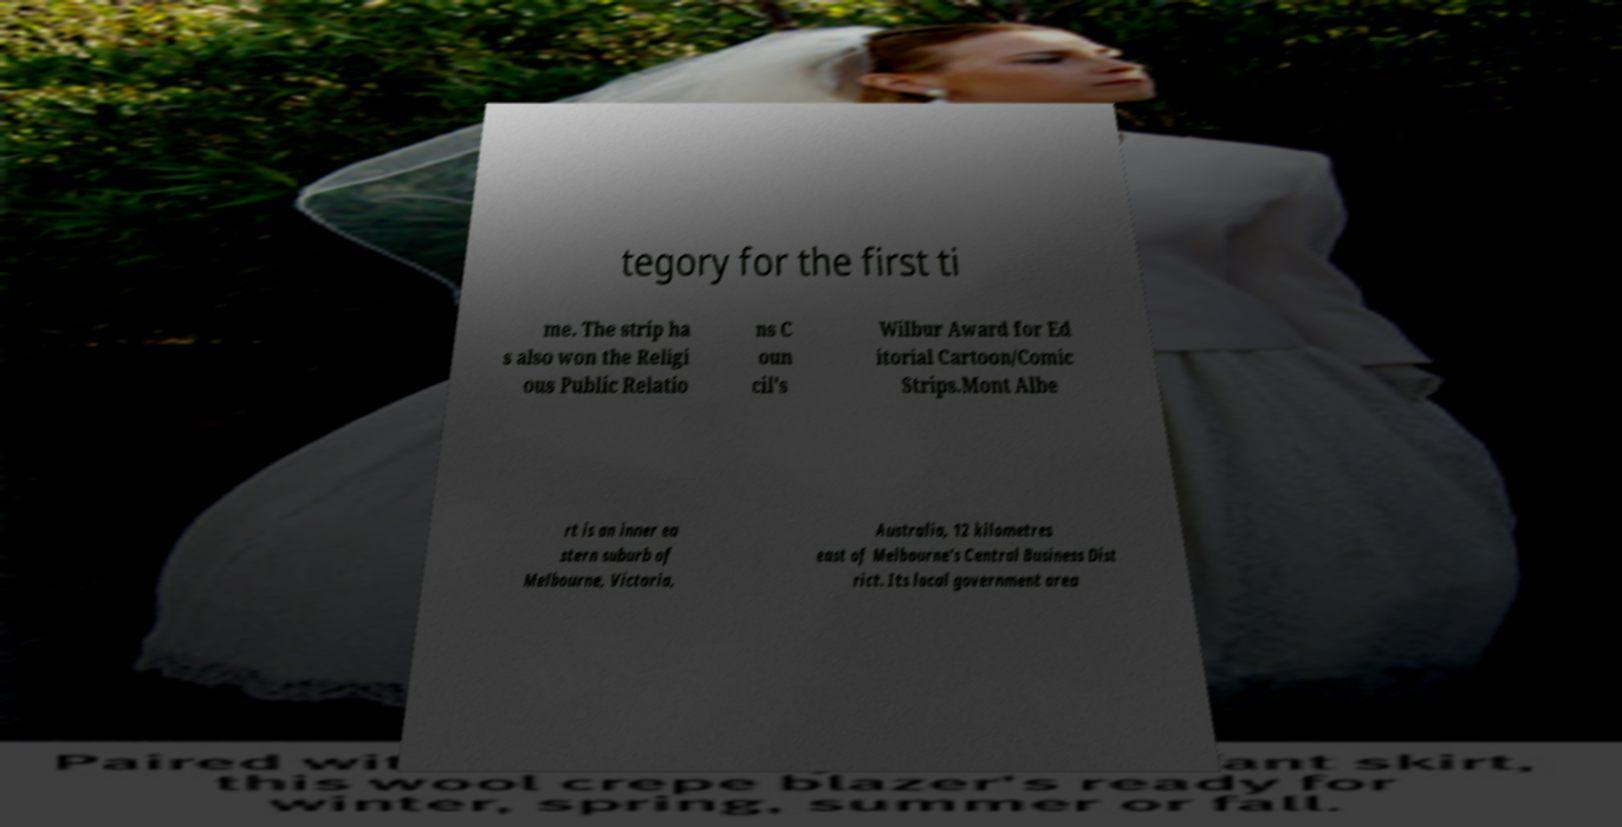Can you accurately transcribe the text from the provided image for me? tegory for the first ti me. The strip ha s also won the Religi ous Public Relatio ns C oun cil's Wilbur Award for Ed itorial Cartoon/Comic Strips.Mont Albe rt is an inner ea stern suburb of Melbourne, Victoria, Australia, 12 kilometres east of Melbourne's Central Business Dist rict. Its local government area 